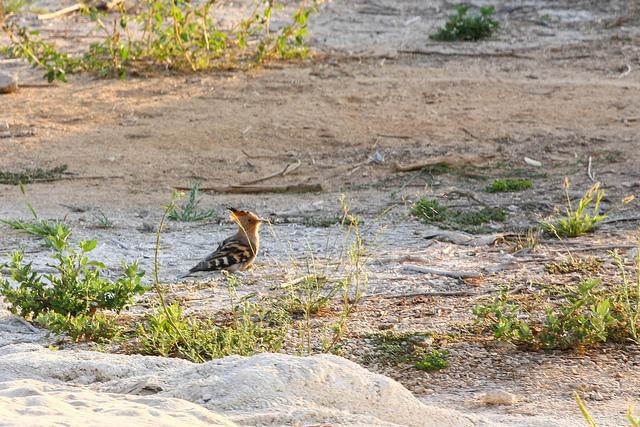What is this bird standing in?
Answer briefly. Sand. What type of bird is this?
Short answer required. Woodpecker. Is this bird in water?
Short answer required. No. What type of bird is in the picture?
Write a very short answer. Woodpecker. What is this animal?
Short answer required. Bird. Is this bird standing in the grass?
Write a very short answer. No. What is the bird standing on?
Answer briefly. Sand. What is in the picture?
Be succinct. Bird. What is the green stuff?
Give a very brief answer. Weeds. Is this bird bigger than a person?
Be succinct. No. What animal is that?
Concise answer only. Bird. 